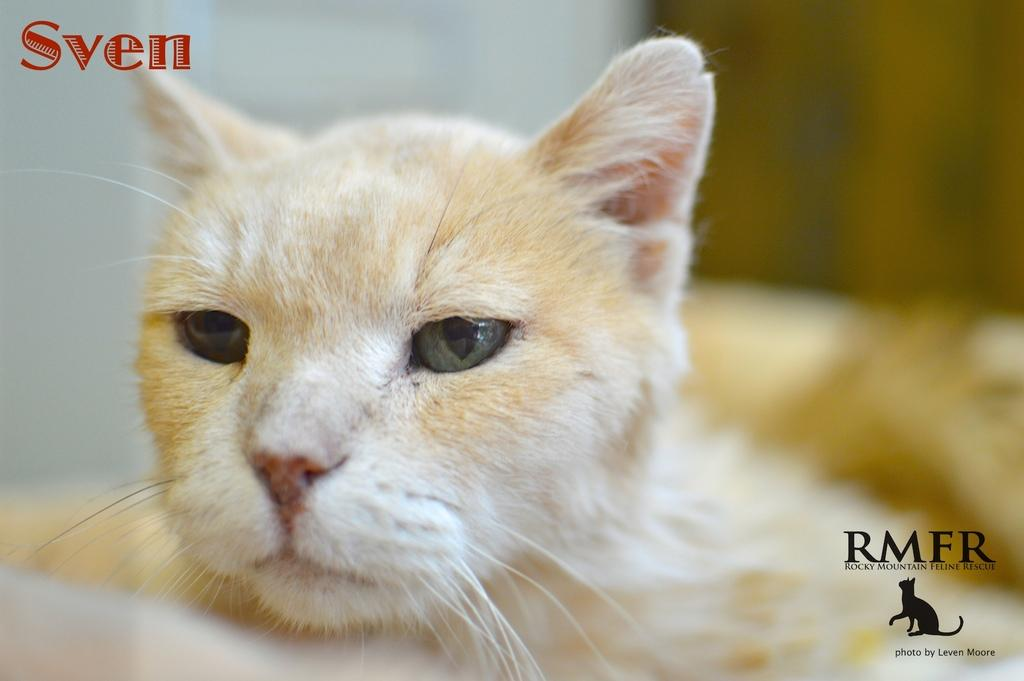What type of animal is in the image? There is a cream-colored cat in the image. Can you describe any other features of the image? Yes, there are watermarks in the top left corner and the bottom right corner of the image. What type of brake system can be seen in the image? There is no brake system present in the image; it features a cream-colored cat and watermarks. What type of pipe is visible in the image? There is no pipe visible in the image; it features a cream-colored cat and watermarks. 